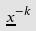<formula> <loc_0><loc_0><loc_500><loc_500>\underline { x } ^ { - k }</formula> 